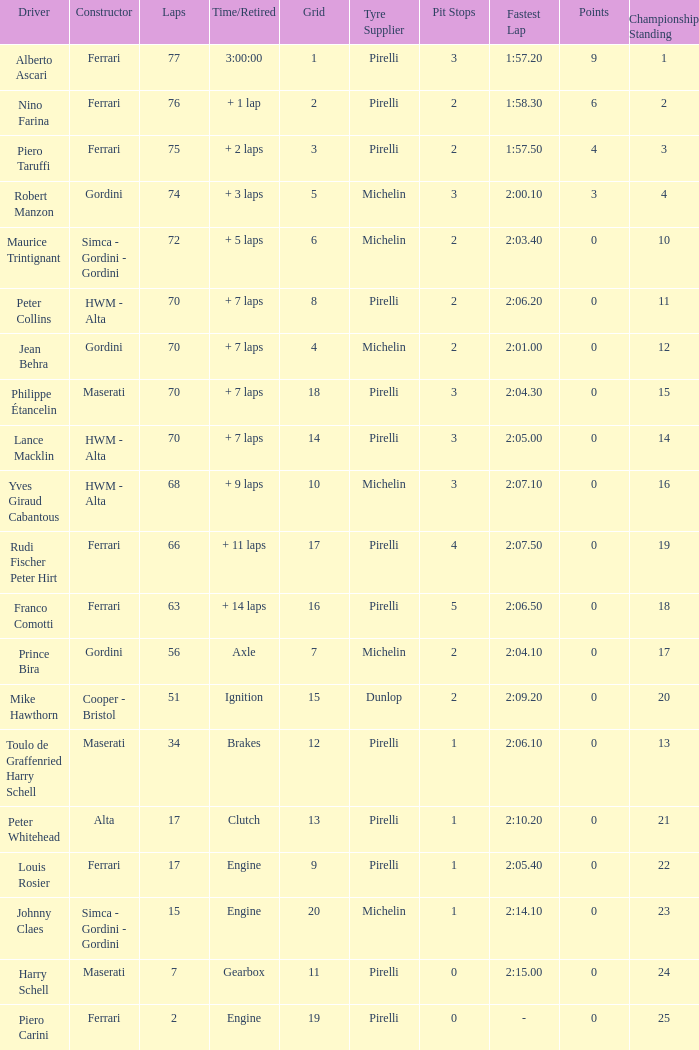Could you help me parse every detail presented in this table? {'header': ['Driver', 'Constructor', 'Laps', 'Time/Retired', 'Grid', 'Tyre Supplier', 'Pit Stops', 'Fastest Lap', 'Points', 'Championship Standing'], 'rows': [['Alberto Ascari', 'Ferrari', '77', '3:00:00', '1', 'Pirelli', '3', '1:57.20', '9', '1'], ['Nino Farina', 'Ferrari', '76', '+ 1 lap', '2', 'Pirelli', '2', '1:58.30', '6', '2'], ['Piero Taruffi', 'Ferrari', '75', '+ 2 laps', '3', 'Pirelli', '2', '1:57.50', '4', '3'], ['Robert Manzon', 'Gordini', '74', '+ 3 laps', '5', 'Michelin', '3', '2:00.10', '3', '4'], ['Maurice Trintignant', 'Simca - Gordini - Gordini', '72', '+ 5 laps', '6', 'Michelin', '2', '2:03.40', '0', '10'], ['Peter Collins', 'HWM - Alta', '70', '+ 7 laps', '8', 'Pirelli', '2', '2:06.20', '0', '11'], ['Jean Behra', 'Gordini', '70', '+ 7 laps', '4', 'Michelin', '2', '2:01.00', '0', '12'], ['Philippe Étancelin', 'Maserati', '70', '+ 7 laps', '18', 'Pirelli', '3', '2:04.30', '0', '15'], ['Lance Macklin', 'HWM - Alta', '70', '+ 7 laps', '14', 'Pirelli', '3', '2:05.00', '0', '14'], ['Yves Giraud Cabantous', 'HWM - Alta', '68', '+ 9 laps', '10', 'Michelin', '3', '2:07.10', '0', '16'], ['Rudi Fischer Peter Hirt', 'Ferrari', '66', '+ 11 laps', '17', 'Pirelli', '4', '2:07.50', '0', '19'], ['Franco Comotti', 'Ferrari', '63', '+ 14 laps', '16', 'Pirelli', '5', '2:06.50', '0', '18'], ['Prince Bira', 'Gordini', '56', 'Axle', '7', 'Michelin', '2', '2:04.10', '0', '17'], ['Mike Hawthorn', 'Cooper - Bristol', '51', 'Ignition', '15', 'Dunlop', '2', '2:09.20', '0', '20'], ['Toulo de Graffenried Harry Schell', 'Maserati', '34', 'Brakes', '12', 'Pirelli', '1', '2:06.10', '0', '13'], ['Peter Whitehead', 'Alta', '17', 'Clutch', '13', 'Pirelli', '1', '2:10.20', '0', '21'], ['Louis Rosier', 'Ferrari', '17', 'Engine', '9', 'Pirelli', '1', '2:05.40', '0', '22'], ['Johnny Claes', 'Simca - Gordini - Gordini', '15', 'Engine', '20', 'Michelin', '1', '2:14.10', '0', '23'], ['Harry Schell', 'Maserati', '7', 'Gearbox', '11', 'Pirelli', '0', '2:15.00', '0', '24'], ['Piero Carini', 'Ferrari', '2', 'Engine', '19', 'Pirelli', '0', '-', '0', '25']]} What is the high grid for ferrari's with 2 laps? 19.0. 